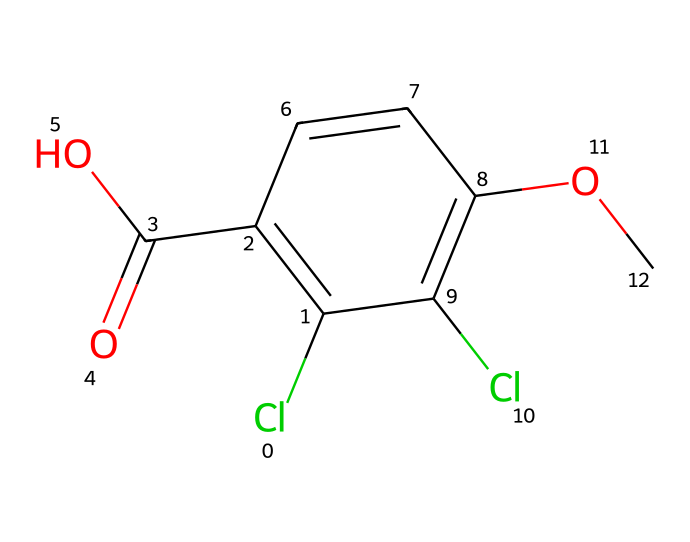What is the molecular formula of dicamba? By analyzing the SMILES representation, we can count the elements represented. The chemical contains 10 carbon atoms (C), 9 hydrogen atoms (H), 2 chlorine atoms (Cl), and 4 oxygen atoms (O). This gives us the molecular formula C10H9Cl2O4.
Answer: C10H9Cl2O4 How many rings are present in the structure of dicamba? The SMILES indicates a cyclic structure as it contains a 'C1' which indicates the start and end of a ring. By examining the structure, there is only one ring present in dicamba.
Answer: 1 What type of chemical is dicamba classified as? Dicamba is specifically used as a herbicide, which is a type of agrochemical designed to kill unwanted plants.
Answer: herbicide What functional groups are present in the structure of dicamba? In the SMILES representation, the presence of 'C(=O)O' indicates a carboxylic acid group, and 'OC' indicates the presence of an ether. Therefore, dicamba has a carboxylic acid and an ether functional group.
Answer: carboxylic acid, ether What is the significance of the chlorine atoms in dicamba's structure? The chlorine atoms in the structure influence the herbicidal activity and chemical stability of dicamba. Their electronegative nature affects the herbicide's interaction with target enzymes in plants, enhancing its effectiveness.
Answer: enhance effectiveness What is the total number of all atoms present in dicamba? By summing the individual elements in the molecular formula, we find 10 Carbons, 9 Hydrogens, 2 Chlorines, and 4 Oxygens, which gives us a total of 25 atoms.
Answer: 25 